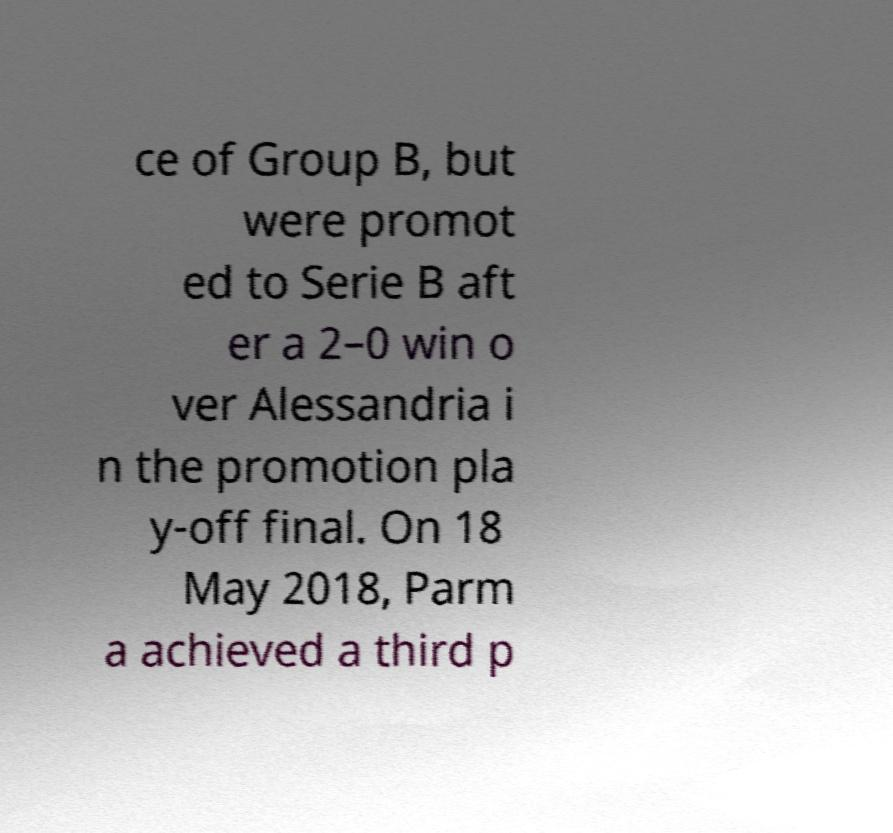I need the written content from this picture converted into text. Can you do that? ce of Group B, but were promot ed to Serie B aft er a 2–0 win o ver Alessandria i n the promotion pla y-off final. On 18 May 2018, Parm a achieved a third p 